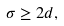<formula> <loc_0><loc_0><loc_500><loc_500>\sigma \geq 2 d ,</formula> 